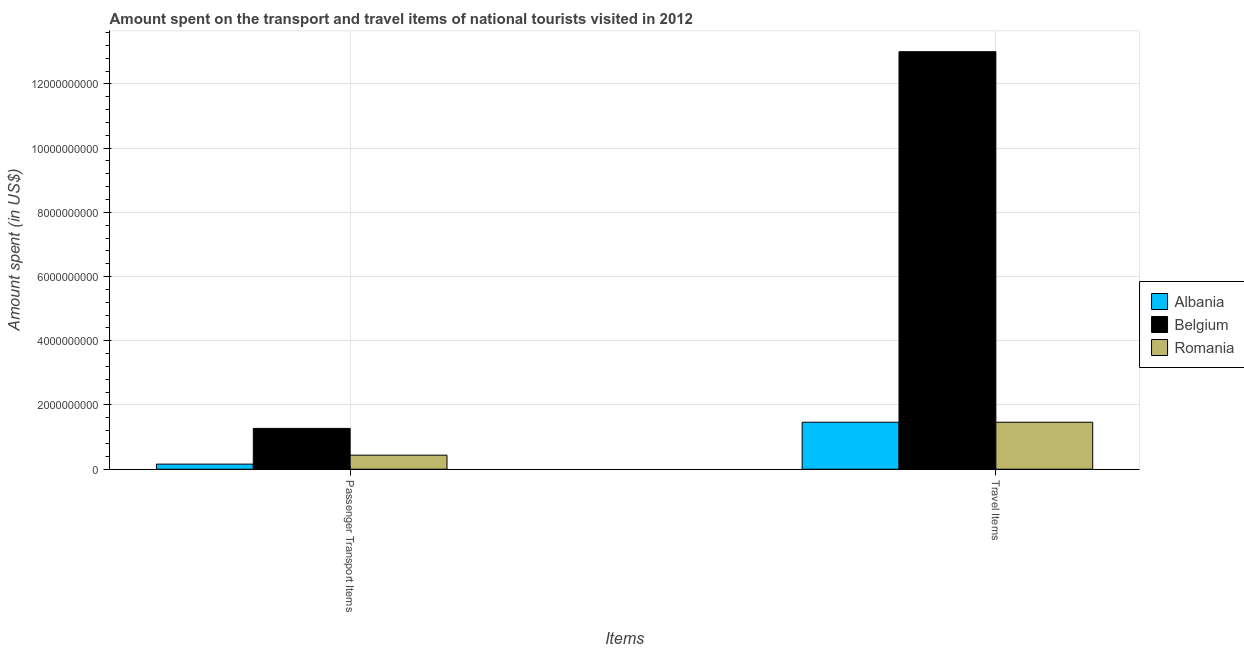Are the number of bars per tick equal to the number of legend labels?
Provide a short and direct response. Yes. Are the number of bars on each tick of the X-axis equal?
Give a very brief answer. Yes. How many bars are there on the 2nd tick from the left?
Your answer should be compact. 3. What is the label of the 2nd group of bars from the left?
Provide a short and direct response. Travel Items. What is the amount spent in travel items in Albania?
Provide a succinct answer. 1.46e+09. Across all countries, what is the maximum amount spent on passenger transport items?
Your response must be concise. 1.27e+09. Across all countries, what is the minimum amount spent in travel items?
Offer a terse response. 1.46e+09. In which country was the amount spent in travel items maximum?
Your response must be concise. Belgium. In which country was the amount spent in travel items minimum?
Keep it short and to the point. Romania. What is the total amount spent on passenger transport items in the graph?
Provide a succinct answer. 1.87e+09. What is the difference between the amount spent on passenger transport items in Belgium and that in Romania?
Provide a short and direct response. 8.33e+08. What is the difference between the amount spent on passenger transport items in Belgium and the amount spent in travel items in Romania?
Your answer should be compact. -1.92e+08. What is the average amount spent on passenger transport items per country?
Offer a terse response. 6.23e+08. What is the difference between the amount spent on passenger transport items and amount spent in travel items in Albania?
Your answer should be very brief. -1.30e+09. What is the ratio of the amount spent on passenger transport items in Albania to that in Romania?
Provide a short and direct response. 0.36. Is the amount spent on passenger transport items in Belgium less than that in Romania?
Offer a very short reply. No. In how many countries, is the amount spent in travel items greater than the average amount spent in travel items taken over all countries?
Offer a terse response. 1. What does the 1st bar from the left in Travel Items represents?
Provide a succinct answer. Albania. What does the 2nd bar from the right in Travel Items represents?
Give a very brief answer. Belgium. Does the graph contain any zero values?
Give a very brief answer. No. Does the graph contain grids?
Provide a succinct answer. Yes. How many legend labels are there?
Ensure brevity in your answer.  3. What is the title of the graph?
Make the answer very short. Amount spent on the transport and travel items of national tourists visited in 2012. What is the label or title of the X-axis?
Offer a terse response. Items. What is the label or title of the Y-axis?
Ensure brevity in your answer.  Amount spent (in US$). What is the Amount spent (in US$) in Albania in Passenger Transport Items?
Your answer should be compact. 1.59e+08. What is the Amount spent (in US$) in Belgium in Passenger Transport Items?
Provide a short and direct response. 1.27e+09. What is the Amount spent (in US$) of Romania in Passenger Transport Items?
Ensure brevity in your answer.  4.38e+08. What is the Amount spent (in US$) in Albania in Travel Items?
Your answer should be very brief. 1.46e+09. What is the Amount spent (in US$) of Belgium in Travel Items?
Make the answer very short. 1.30e+1. What is the Amount spent (in US$) in Romania in Travel Items?
Provide a short and direct response. 1.46e+09. Across all Items, what is the maximum Amount spent (in US$) of Albania?
Your answer should be very brief. 1.46e+09. Across all Items, what is the maximum Amount spent (in US$) of Belgium?
Offer a terse response. 1.30e+1. Across all Items, what is the maximum Amount spent (in US$) of Romania?
Provide a succinct answer. 1.46e+09. Across all Items, what is the minimum Amount spent (in US$) of Albania?
Give a very brief answer. 1.59e+08. Across all Items, what is the minimum Amount spent (in US$) in Belgium?
Provide a succinct answer. 1.27e+09. Across all Items, what is the minimum Amount spent (in US$) of Romania?
Offer a very short reply. 4.38e+08. What is the total Amount spent (in US$) of Albania in the graph?
Give a very brief answer. 1.62e+09. What is the total Amount spent (in US$) of Belgium in the graph?
Your response must be concise. 1.43e+1. What is the total Amount spent (in US$) of Romania in the graph?
Keep it short and to the point. 1.90e+09. What is the difference between the Amount spent (in US$) in Albania in Passenger Transport Items and that in Travel Items?
Your answer should be compact. -1.30e+09. What is the difference between the Amount spent (in US$) in Belgium in Passenger Transport Items and that in Travel Items?
Your answer should be very brief. -1.17e+1. What is the difference between the Amount spent (in US$) of Romania in Passenger Transport Items and that in Travel Items?
Provide a short and direct response. -1.02e+09. What is the difference between the Amount spent (in US$) of Albania in Passenger Transport Items and the Amount spent (in US$) of Belgium in Travel Items?
Your answer should be compact. -1.28e+1. What is the difference between the Amount spent (in US$) of Albania in Passenger Transport Items and the Amount spent (in US$) of Romania in Travel Items?
Make the answer very short. -1.30e+09. What is the difference between the Amount spent (in US$) of Belgium in Passenger Transport Items and the Amount spent (in US$) of Romania in Travel Items?
Give a very brief answer. -1.92e+08. What is the average Amount spent (in US$) in Albania per Items?
Make the answer very short. 8.12e+08. What is the average Amount spent (in US$) in Belgium per Items?
Provide a short and direct response. 7.14e+09. What is the average Amount spent (in US$) of Romania per Items?
Your response must be concise. 9.50e+08. What is the difference between the Amount spent (in US$) in Albania and Amount spent (in US$) in Belgium in Passenger Transport Items?
Your response must be concise. -1.11e+09. What is the difference between the Amount spent (in US$) of Albania and Amount spent (in US$) of Romania in Passenger Transport Items?
Your response must be concise. -2.79e+08. What is the difference between the Amount spent (in US$) of Belgium and Amount spent (in US$) of Romania in Passenger Transport Items?
Offer a very short reply. 8.33e+08. What is the difference between the Amount spent (in US$) in Albania and Amount spent (in US$) in Belgium in Travel Items?
Your response must be concise. -1.15e+1. What is the difference between the Amount spent (in US$) of Belgium and Amount spent (in US$) of Romania in Travel Items?
Make the answer very short. 1.15e+1. What is the ratio of the Amount spent (in US$) of Albania in Passenger Transport Items to that in Travel Items?
Your answer should be very brief. 0.11. What is the ratio of the Amount spent (in US$) in Belgium in Passenger Transport Items to that in Travel Items?
Provide a succinct answer. 0.1. What is the ratio of the Amount spent (in US$) of Romania in Passenger Transport Items to that in Travel Items?
Keep it short and to the point. 0.3. What is the difference between the highest and the second highest Amount spent (in US$) in Albania?
Keep it short and to the point. 1.30e+09. What is the difference between the highest and the second highest Amount spent (in US$) in Belgium?
Your response must be concise. 1.17e+1. What is the difference between the highest and the second highest Amount spent (in US$) in Romania?
Make the answer very short. 1.02e+09. What is the difference between the highest and the lowest Amount spent (in US$) of Albania?
Ensure brevity in your answer.  1.30e+09. What is the difference between the highest and the lowest Amount spent (in US$) of Belgium?
Your response must be concise. 1.17e+1. What is the difference between the highest and the lowest Amount spent (in US$) in Romania?
Provide a succinct answer. 1.02e+09. 